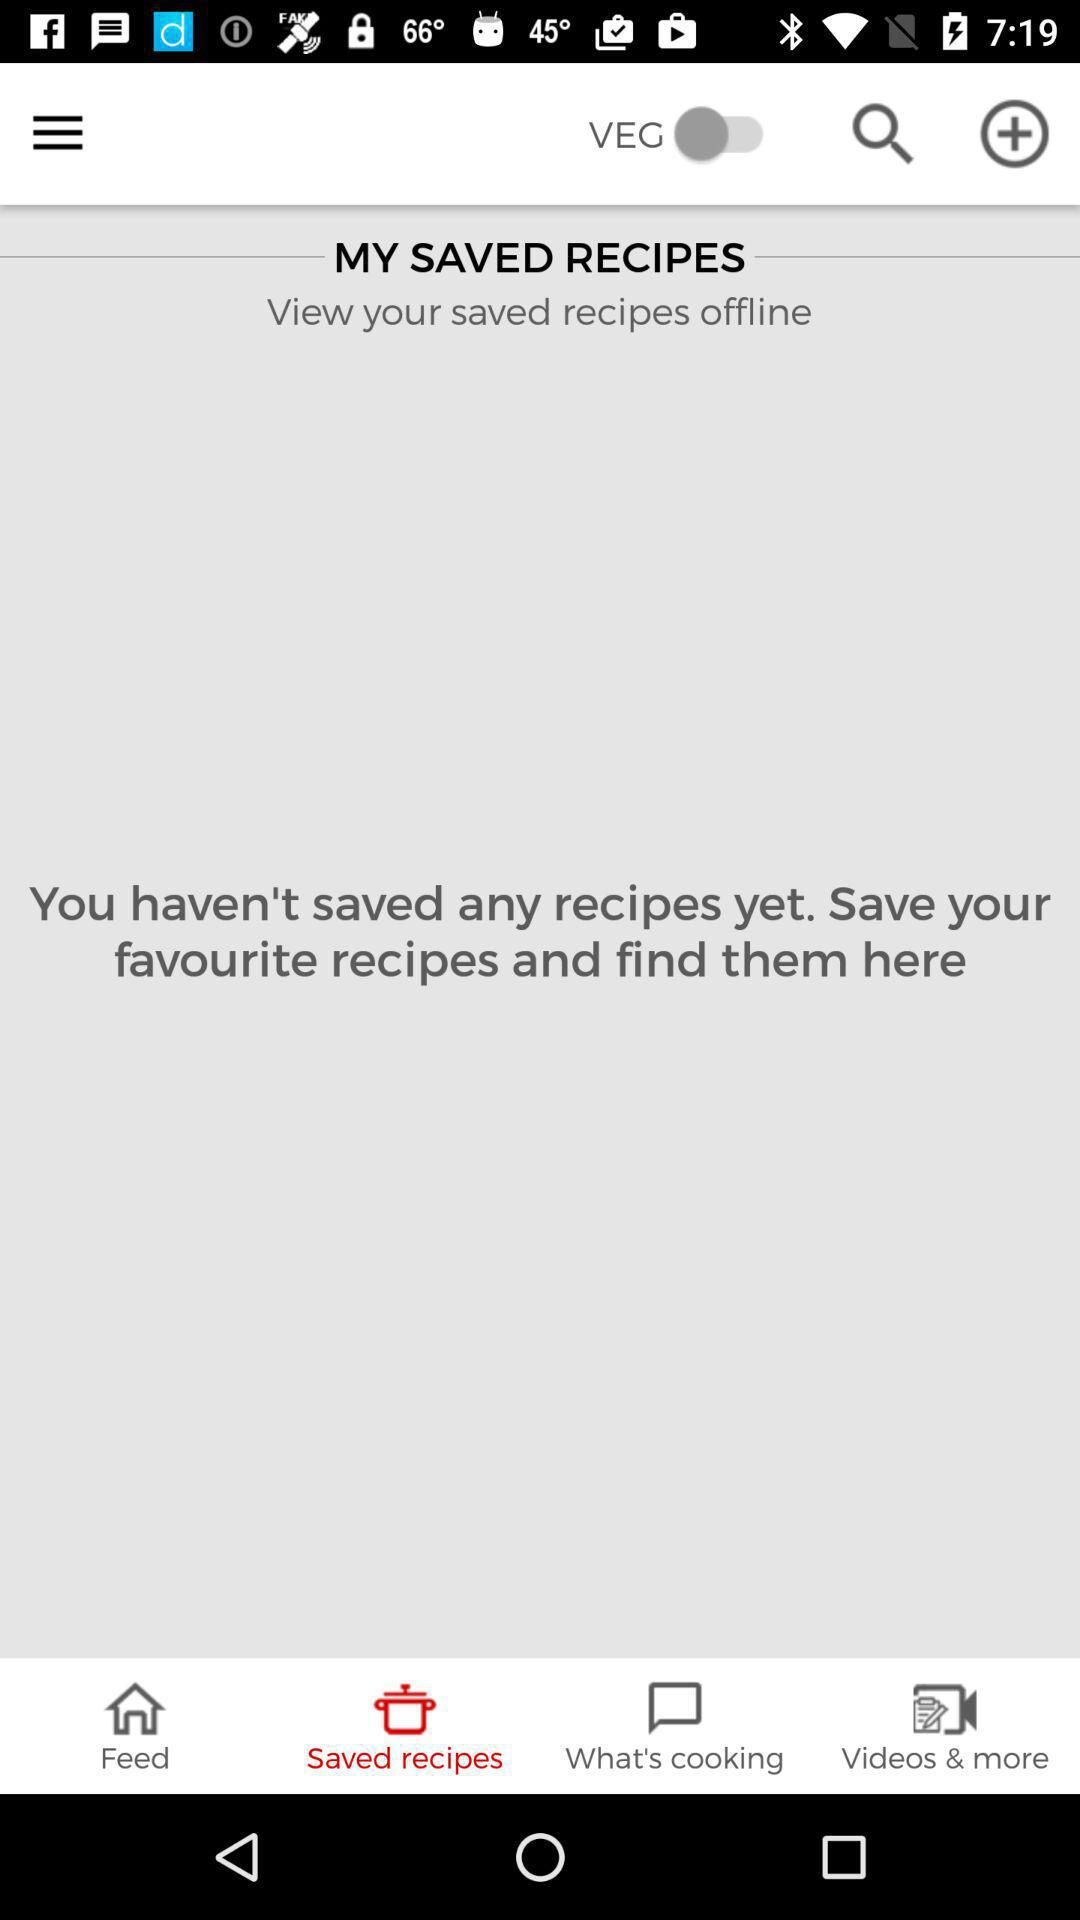Which tab has been selected? The tab that has been selected is "Saved recipes". 